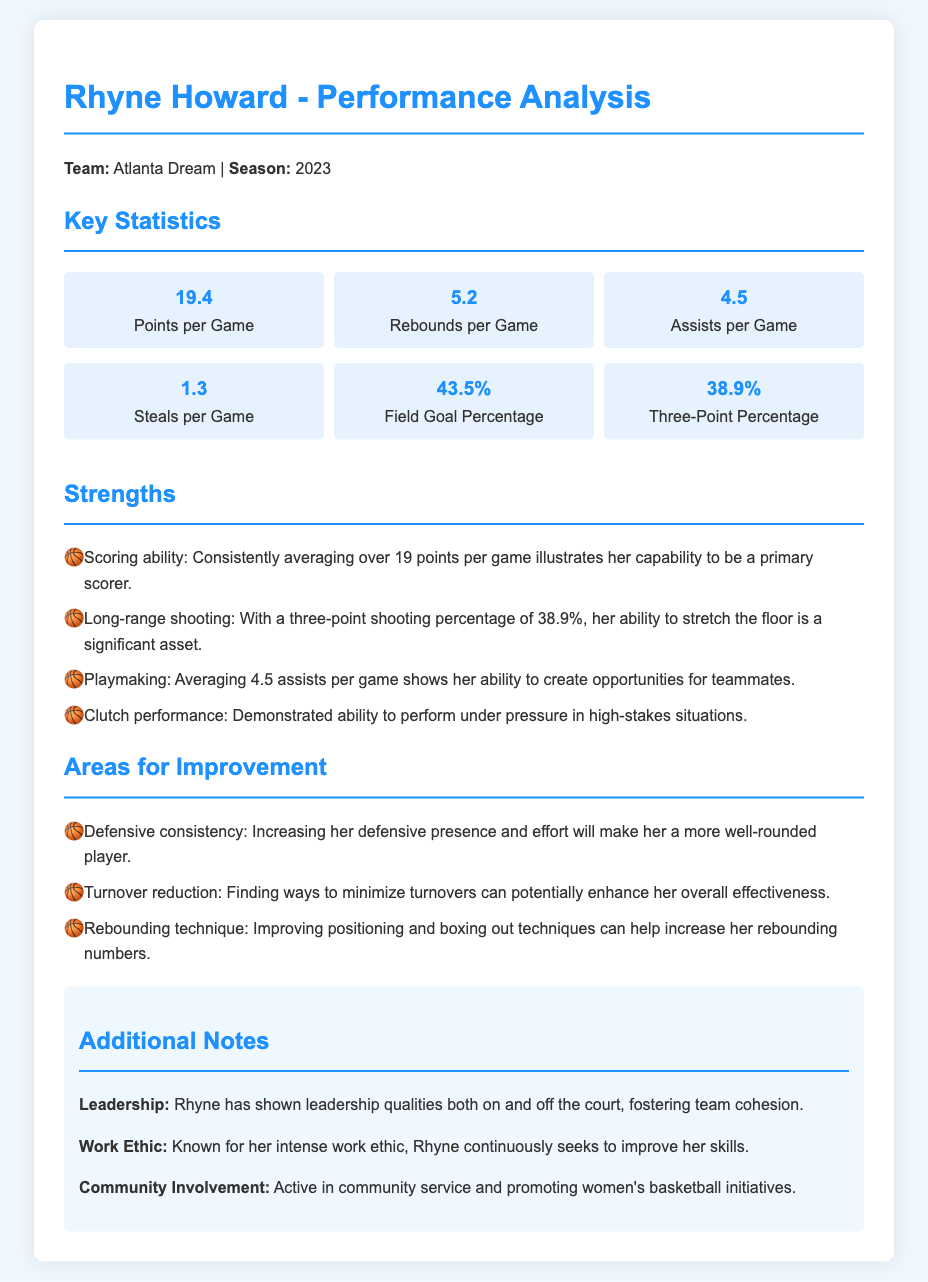What is Rhyne Howard's points per game? Rhyne Howard's points per game statistic is highlighted in the key statistics section of the document, listed as 19.4.
Answer: 19.4 What is Rhyne Howard's three-point shooting percentage? The document provides Rhyne Howard's three-point shooting percentage in the key statistics section, which is 38.9%.
Answer: 38.9% What area should Rhyne improve to become a more well-rounded player? The document lists defensive consistency as an area for improvement in the areas for improvement section, indicating its importance for her overall development.
Answer: Defensive consistency How many rebounds does Rhyne average per game? The average rebounds per game is a statistic included in the key statistics section, which shows that Rhyne averages 5.2 rebounds per game.
Answer: 5.2 What leadership quality has Rhyne Howard shown? The additional notes section mentions Rhyne has shown leadership qualities, indicating her ability to foster team cohesion.
Answer: Leadership qualities What aspect of Rhyne's performance shows her playmaking ability? Rhyne's average assists per game is discussed in the key statistics section, reflecting her playmaking ability with an average of 4.5 assists per game.
Answer: 4.5 assists per game What is a notable strength of Rhyne Howard? The document lists scoring ability as a strength, demonstrating her capability to be a primary scorer in the strengths section.
Answer: Scoring ability What is mentioned about Rhyne's community involvement? The additional notes state that Rhyne is active in community service and promoting women's basketball initiatives, highlighting her engagement off the court.
Answer: Community service What is the field goal percentage for Rhyne Howard? The document provides the field goal percentage statistic in the key statistics section, indicating that it is 43.5%.
Answer: 43.5% 